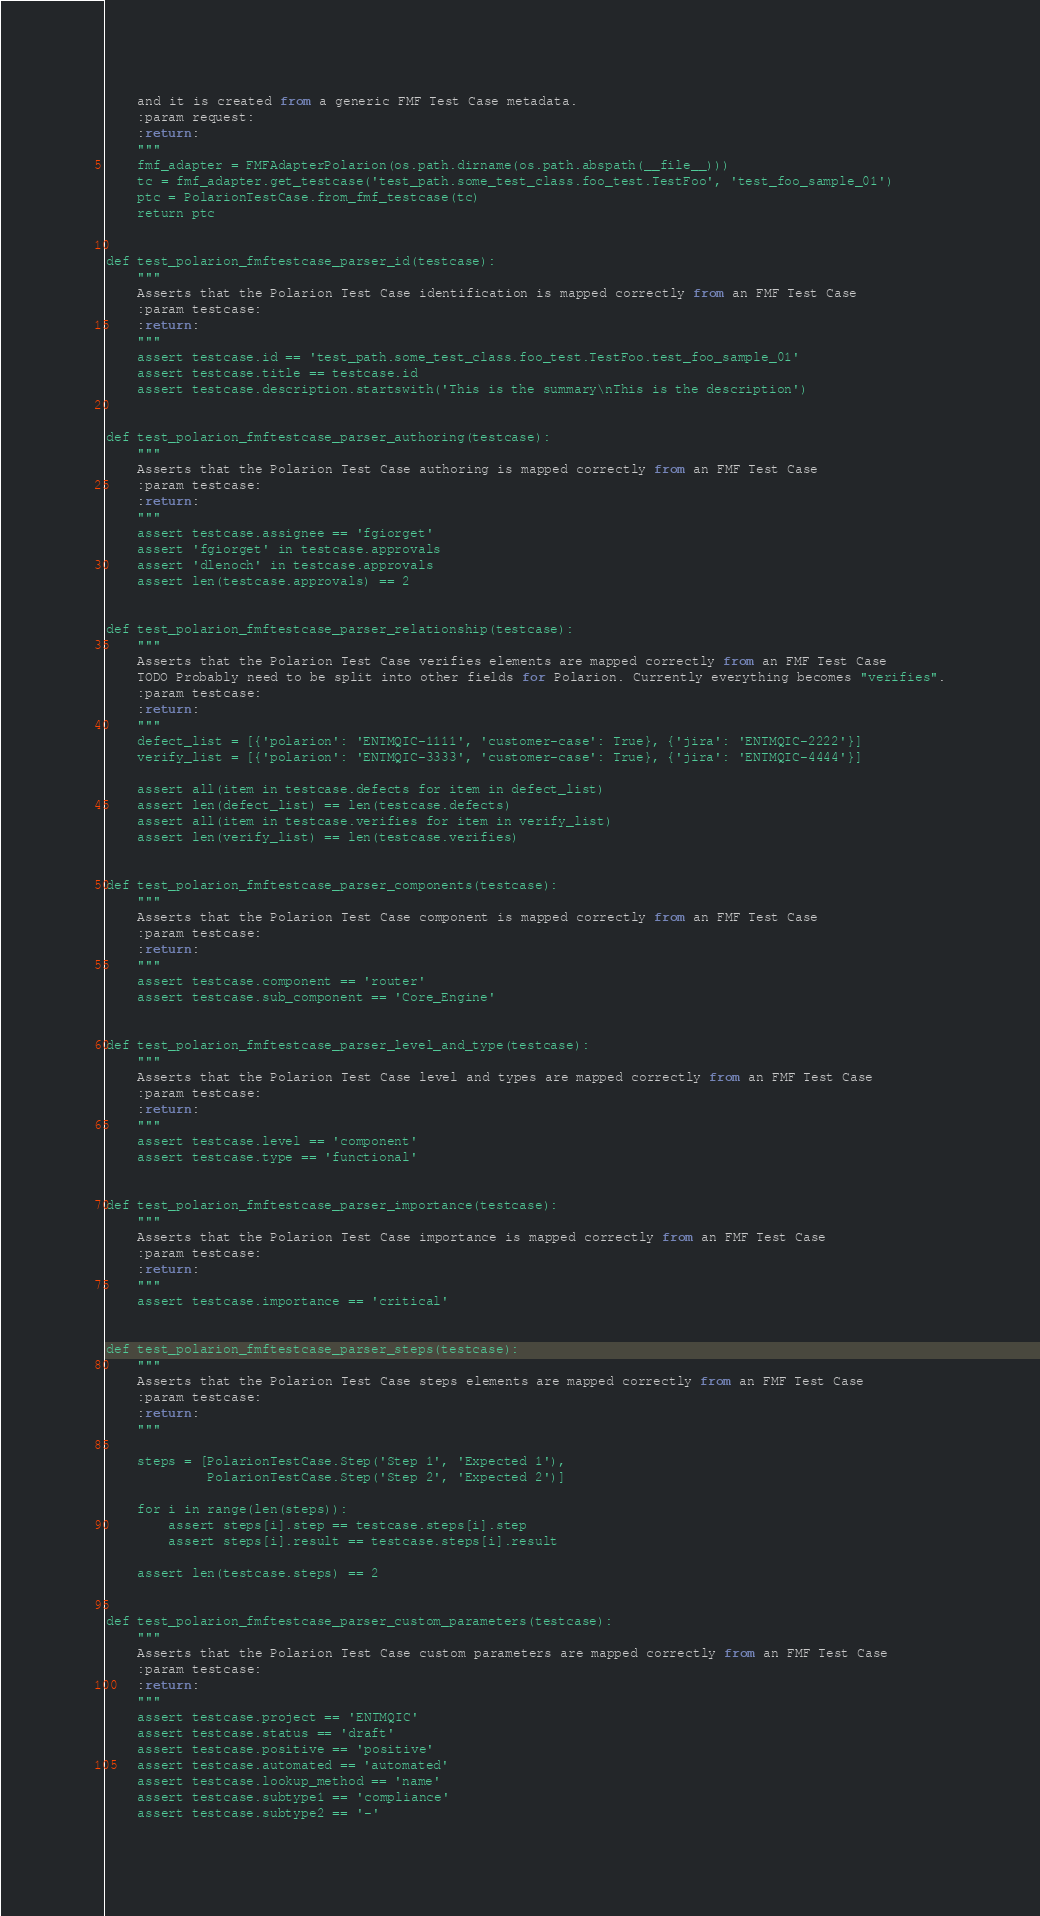<code> <loc_0><loc_0><loc_500><loc_500><_Python_>    and it is created from a generic FMF Test Case metadata.
    :param request:
    :return:
    """
    fmf_adapter = FMFAdapterPolarion(os.path.dirname(os.path.abspath(__file__)))
    tc = fmf_adapter.get_testcase('test_path.some_test_class.foo_test.TestFoo', 'test_foo_sample_01')
    ptc = PolarionTestCase.from_fmf_testcase(tc)
    return ptc


def test_polarion_fmftestcase_parser_id(testcase):
    """
    Asserts that the Polarion Test Case identification is mapped correctly from an FMF Test Case
    :param testcase:
    :return:
    """
    assert testcase.id == 'test_path.some_test_class.foo_test.TestFoo.test_foo_sample_01'
    assert testcase.title == testcase.id
    assert testcase.description.startswith('This is the summary\nThis is the description')


def test_polarion_fmftestcase_parser_authoring(testcase):
    """
    Asserts that the Polarion Test Case authoring is mapped correctly from an FMF Test Case
    :param testcase:
    :return:
    """
    assert testcase.assignee == 'fgiorget'
    assert 'fgiorget' in testcase.approvals
    assert 'dlenoch' in testcase.approvals
    assert len(testcase.approvals) == 2


def test_polarion_fmftestcase_parser_relationship(testcase):
    """
    Asserts that the Polarion Test Case verifies elements are mapped correctly from an FMF Test Case
    TODO Probably need to be split into other fields for Polarion. Currently everything becomes "verifies".
    :param testcase:
    :return:
    """
    defect_list = [{'polarion': 'ENTMQIC-1111', 'customer-case': True}, {'jira': 'ENTMQIC-2222'}]
    verify_list = [{'polarion': 'ENTMQIC-3333', 'customer-case': True}, {'jira': 'ENTMQIC-4444'}]

    assert all(item in testcase.defects for item in defect_list)
    assert len(defect_list) == len(testcase.defects)
    assert all(item in testcase.verifies for item in verify_list)
    assert len(verify_list) == len(testcase.verifies)


def test_polarion_fmftestcase_parser_components(testcase):
    """
    Asserts that the Polarion Test Case component is mapped correctly from an FMF Test Case
    :param testcase:
    :return:
    """
    assert testcase.component == 'router'
    assert testcase.sub_component == 'Core_Engine'


def test_polarion_fmftestcase_parser_level_and_type(testcase):
    """
    Asserts that the Polarion Test Case level and types are mapped correctly from an FMF Test Case
    :param testcase:
    :return:
    """
    assert testcase.level == 'component'
    assert testcase.type == 'functional'


def test_polarion_fmftestcase_parser_importance(testcase):
    """
    Asserts that the Polarion Test Case importance is mapped correctly from an FMF Test Case
    :param testcase:
    :return:
    """
    assert testcase.importance == 'critical'


def test_polarion_fmftestcase_parser_steps(testcase):
    """
    Asserts that the Polarion Test Case steps elements are mapped correctly from an FMF Test Case
    :param testcase:
    :return:
    """

    steps = [PolarionTestCase.Step('Step 1', 'Expected 1'),
             PolarionTestCase.Step('Step 2', 'Expected 2')]

    for i in range(len(steps)):
        assert steps[i].step == testcase.steps[i].step
        assert steps[i].result == testcase.steps[i].result

    assert len(testcase.steps) == 2


def test_polarion_fmftestcase_parser_custom_parameters(testcase):
    """
    Asserts that the Polarion Test Case custom parameters are mapped correctly from an FMF Test Case
    :param testcase:
    :return:
    """
    assert testcase.project == 'ENTMQIC'
    assert testcase.status == 'draft'
    assert testcase.positive == 'positive'
    assert testcase.automated == 'automated'
    assert testcase.lookup_method == 'name'
    assert testcase.subtype1 == 'compliance'
    assert testcase.subtype2 == '-'
</code> 